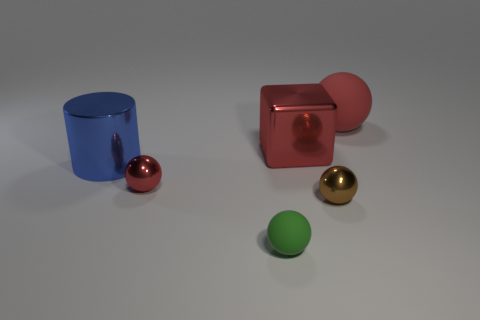What number of matte balls are in front of the big cube and right of the big cube?
Ensure brevity in your answer.  0. Does the green matte ball have the same size as the brown metal object?
Offer a terse response. Yes. There is a red sphere that is to the right of the green rubber ball; does it have the same size as the blue metal cylinder?
Your answer should be compact. Yes. There is a large object left of the green ball; what is its color?
Your answer should be compact. Blue. What number of big metal objects are there?
Offer a terse response. 2. There is a small object that is the same material as the tiny brown ball; what shape is it?
Your answer should be very brief. Sphere. There is a tiny metallic sphere that is right of the green matte thing; is its color the same as the big object that is right of the red metallic cube?
Provide a succinct answer. No. Are there an equal number of blue metallic cylinders in front of the tiny red metal sphere and blue metal objects?
Offer a very short reply. No. There is a brown metallic ball; what number of rubber objects are behind it?
Provide a short and direct response. 1. How big is the green object?
Your answer should be compact. Small. 